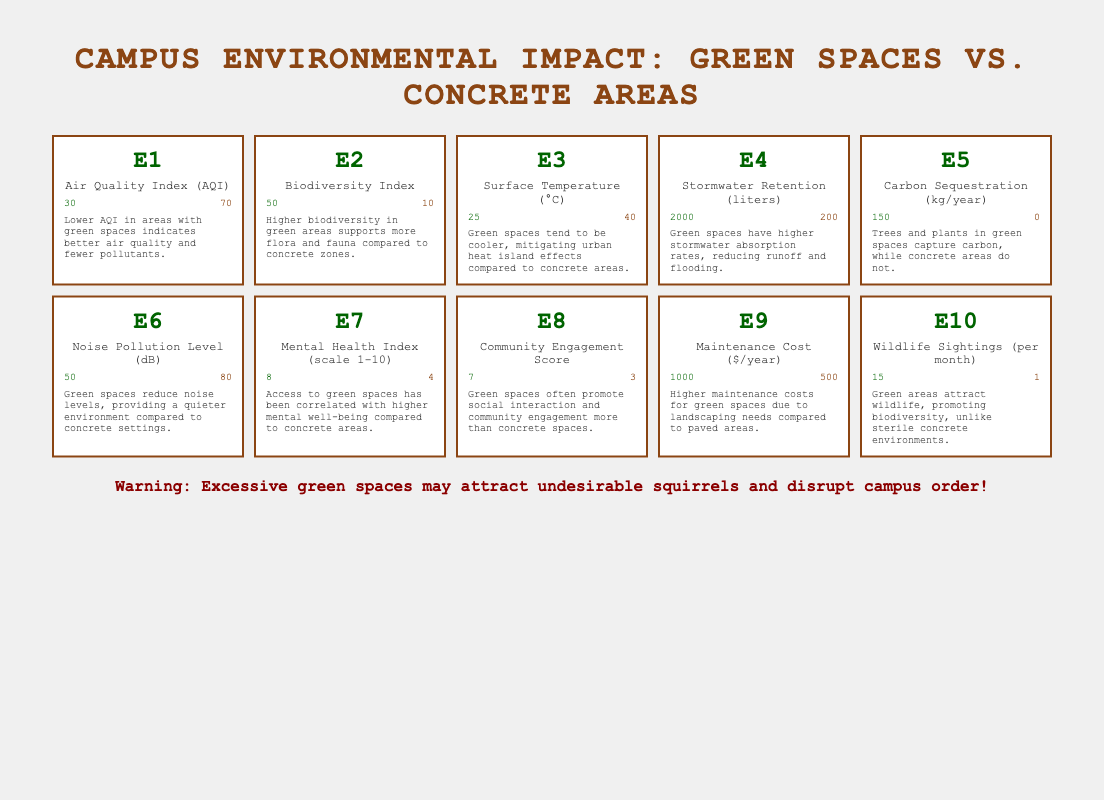What is the Air Quality Index (AQI) value for green spaces? The table indicates that the AQI value for green spaces is 30.
Answer: 30 What is the difference in the Noise Pollution Level (dB) between green spaces and concrete areas? The noise pollution level for green spaces is 50 dB and for concrete areas, it is 80 dB. The difference is 80 - 50 = 30 dB.
Answer: 30 dB Is the Biodiversity Index higher in green spaces than in concrete areas? Yes, the Biodiversity Index for green spaces is 50 while it is 10 for concrete areas, indicating higher biodiversity in green spaces.
Answer: Yes What is the total Stormwater Retention for green spaces and concrete areas combined? For green spaces, the stormwater retention is 2000 liters and for concrete areas, it is 200 liters. Adding them together gives 2000 + 200 = 2200 liters.
Answer: 2200 liters What is the average Mental Health Index for green spaces and concrete areas? The Mental Health Index for green spaces is 8 and for concrete areas, it is 4. To find the average, we sum the values (8 + 4 = 12) and divide by the number of data points (2), getting 12 / 2 = 6.
Answer: 6 How much Carbon Sequestration does green space achieve compared to concrete areas? Green spaces sequester 150 kg/year, while concrete areas do not sequester any carbon, with a value of 0 kg/year. Thus, green spaces achieve 150 kg/year more than concrete areas.
Answer: 150 kg/year Is the Maintenance Cost of green spaces less than that of concrete areas? No, the Maintenance Cost for green spaces is $1000/year, which is higher compared to $500/year for concrete areas.
Answer: No How many Wildlife Sightings occur per month in green spaces compared to concrete areas? The table shows 15 wildlife sightings per month in green spaces and only 1 in concrete areas. This indicates that green spaces have significantly more wildlife sightings than concrete areas.
Answer: 15 vs. 1 What percentage of stormwater is retained by green spaces compared to concrete areas? Green spaces retain 2000 liters of stormwater and concrete areas retain 200 liters. To find the percentage, we calculate (2000 / (2000 + 200)) * 100 = (2000 / 2200) * 100 ≈ 90.91%.
Answer: 90.91% 